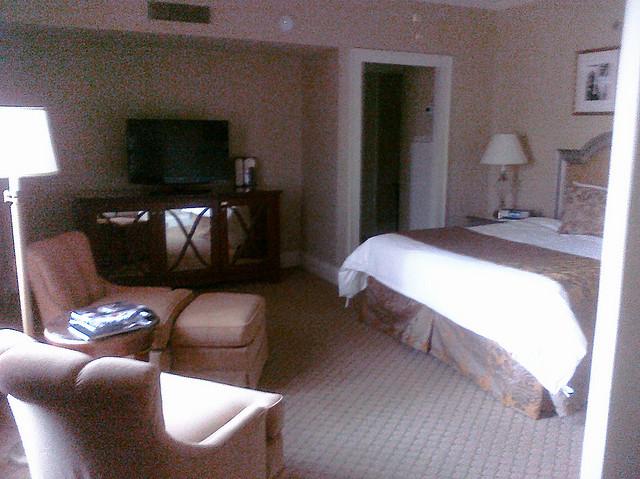Is the TV on?
Concise answer only. No. If a fire broke out in this room, would anything in it alert the occupants?
Answer briefly. Yes. Is there a light on?
Concise answer only. Yes. 